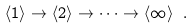Convert formula to latex. <formula><loc_0><loc_0><loc_500><loc_500>\langle 1 \rangle \to \langle 2 \rangle \to \dots \to \langle \infty \rangle \ .</formula> 